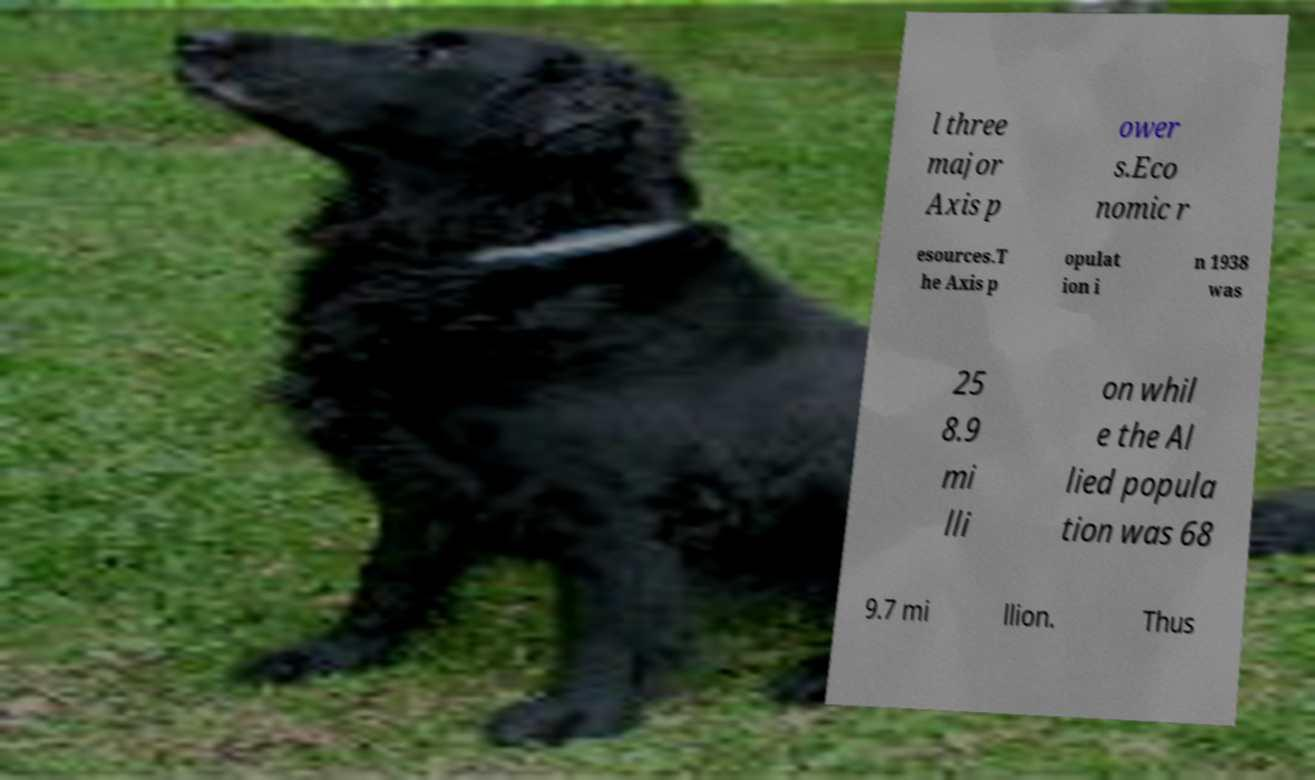There's text embedded in this image that I need extracted. Can you transcribe it verbatim? l three major Axis p ower s.Eco nomic r esources.T he Axis p opulat ion i n 1938 was 25 8.9 mi lli on whil e the Al lied popula tion was 68 9.7 mi llion. Thus 